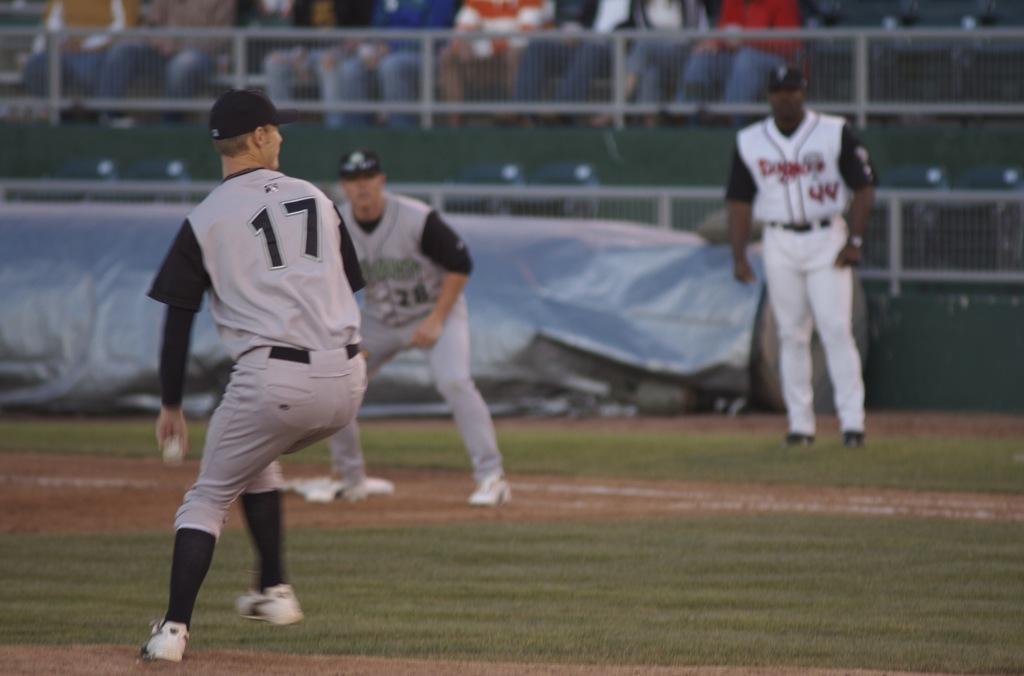What is the jersey number of the man in the back right?
Provide a short and direct response. 44. 